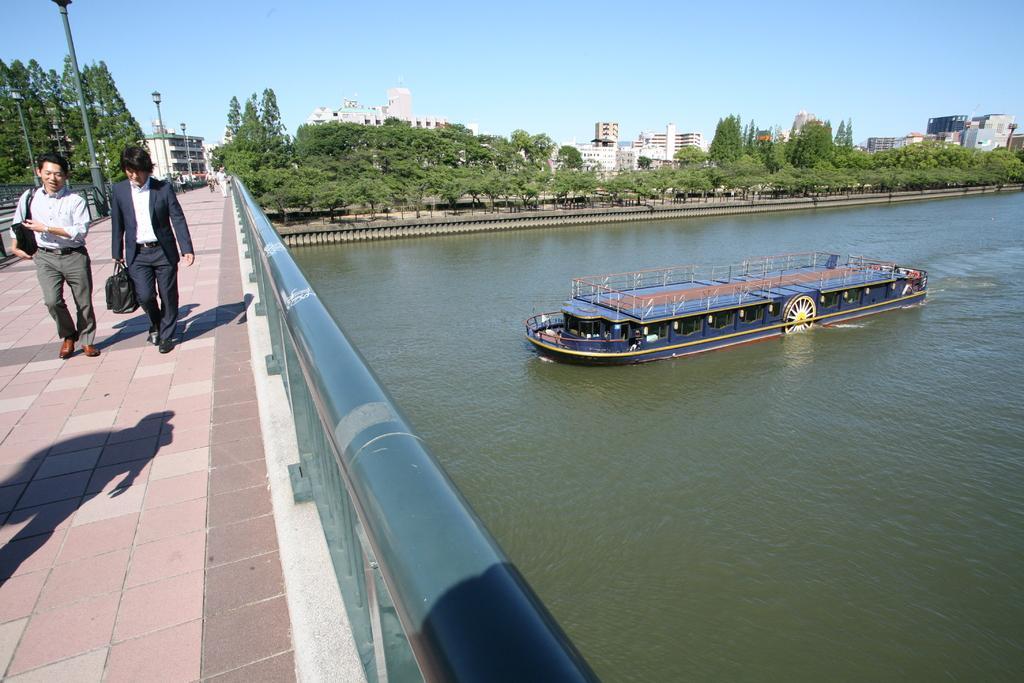Describe this image in one or two sentences. In the picture we can see some persons walking along the bridge, on right side of the picture there is a ship which is moving on water and in the background of the picture there are some trees and buildings and top of the picture there is clear sky. 